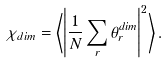Convert formula to latex. <formula><loc_0><loc_0><loc_500><loc_500>\chi _ { d i m } = \left \langle \left | \frac { 1 } { N } \sum _ { r } \theta ^ { d i m } _ { r } \right | ^ { 2 } \right \rangle .</formula> 